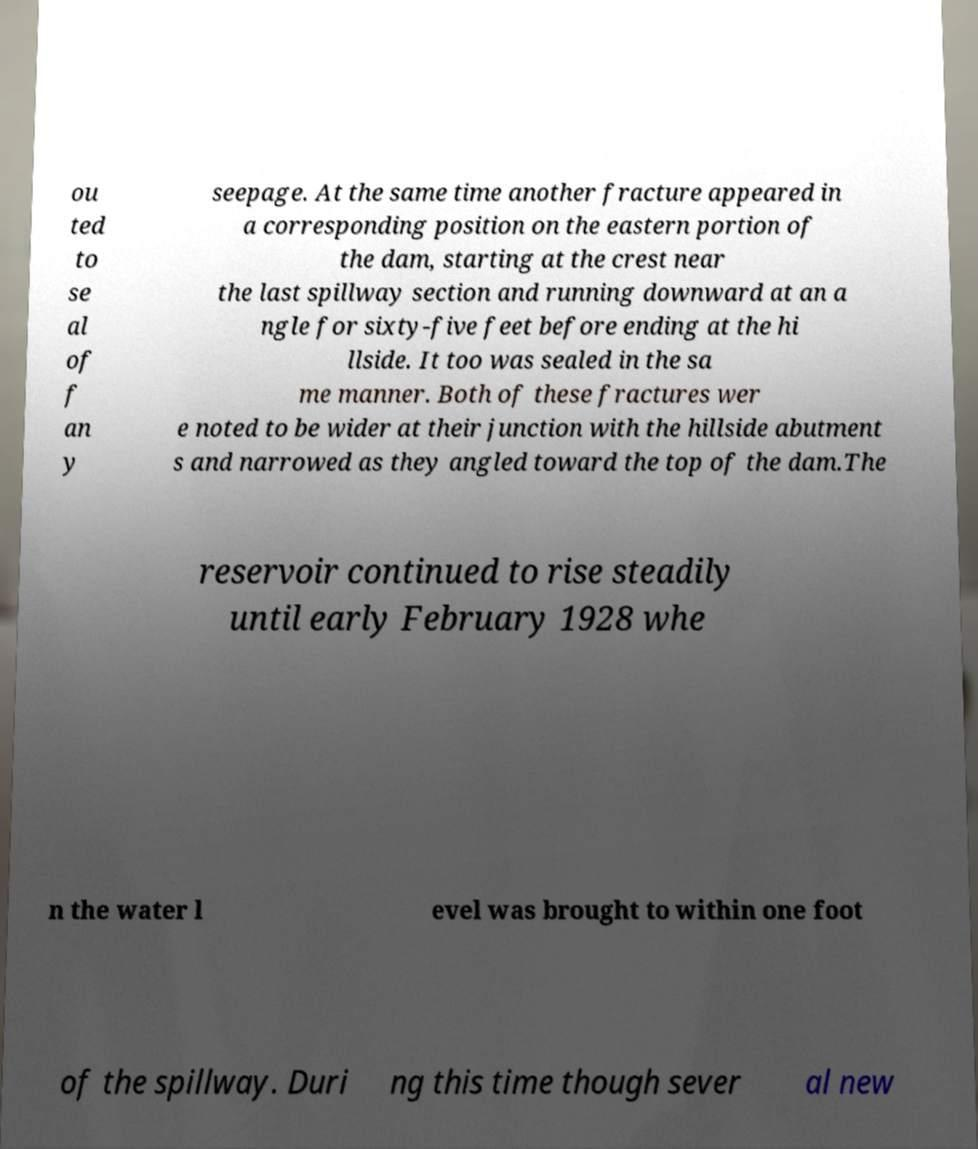Can you read and provide the text displayed in the image?This photo seems to have some interesting text. Can you extract and type it out for me? ou ted to se al of f an y seepage. At the same time another fracture appeared in a corresponding position on the eastern portion of the dam, starting at the crest near the last spillway section and running downward at an a ngle for sixty-five feet before ending at the hi llside. It too was sealed in the sa me manner. Both of these fractures wer e noted to be wider at their junction with the hillside abutment s and narrowed as they angled toward the top of the dam.The reservoir continued to rise steadily until early February 1928 whe n the water l evel was brought to within one foot of the spillway. Duri ng this time though sever al new 